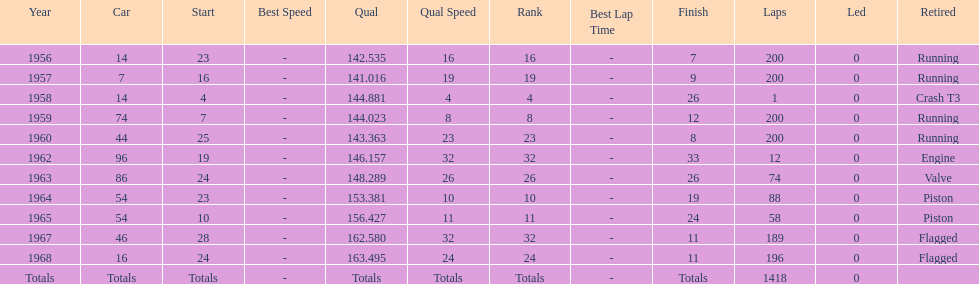How many times was bob veith ranked higher than 10 at an indy 500? 2. Would you be able to parse every entry in this table? {'header': ['Year', 'Car', 'Start', 'Best Speed', 'Qual', 'Qual Speed', 'Rank', 'Best Lap Time', 'Finish', 'Laps', 'Led', 'Retired'], 'rows': [['1956', '14', '23', '-', '142.535', '16', '16', '-', '7', '200', '0', 'Running'], ['1957', '7', '16', '-', '141.016', '19', '19', '-', '9', '200', '0', 'Running'], ['1958', '14', '4', '-', '144.881', '4', '4', '-', '26', '1', '0', 'Crash T3'], ['1959', '74', '7', '-', '144.023', '8', '8', '-', '12', '200', '0', 'Running'], ['1960', '44', '25', '-', '143.363', '23', '23', '-', '8', '200', '0', 'Running'], ['1962', '96', '19', '-', '146.157', '32', '32', '-', '33', '12', '0', 'Engine'], ['1963', '86', '24', '-', '148.289', '26', '26', '-', '26', '74', '0', 'Valve'], ['1964', '54', '23', '-', '153.381', '10', '10', '-', '19', '88', '0', 'Piston'], ['1965', '54', '10', '-', '156.427', '11', '11', '-', '24', '58', '0', 'Piston'], ['1967', '46', '28', '-', '162.580', '32', '32', '-', '11', '189', '0', 'Flagged'], ['1968', '16', '24', '-', '163.495', '24', '24', '-', '11', '196', '0', 'Flagged'], ['Totals', 'Totals', 'Totals', '-', 'Totals', 'Totals', 'Totals', '-', 'Totals', '1418', '0', '']]} 